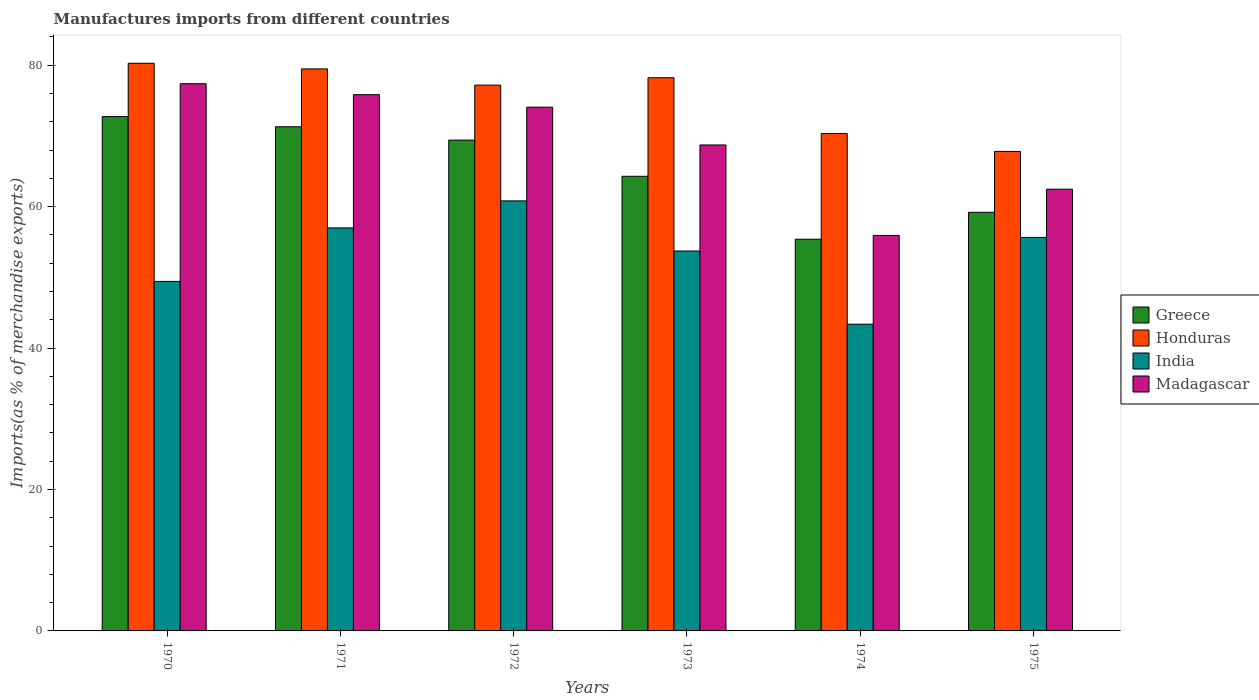Are the number of bars per tick equal to the number of legend labels?
Your answer should be compact. Yes. Are the number of bars on each tick of the X-axis equal?
Your response must be concise. Yes. How many bars are there on the 6th tick from the left?
Your response must be concise. 4. What is the label of the 6th group of bars from the left?
Provide a succinct answer. 1975. In how many cases, is the number of bars for a given year not equal to the number of legend labels?
Provide a short and direct response. 0. What is the percentage of imports to different countries in India in 1971?
Offer a terse response. 56.99. Across all years, what is the maximum percentage of imports to different countries in Greece?
Your response must be concise. 72.73. Across all years, what is the minimum percentage of imports to different countries in Greece?
Keep it short and to the point. 55.39. In which year was the percentage of imports to different countries in India maximum?
Keep it short and to the point. 1972. In which year was the percentage of imports to different countries in India minimum?
Make the answer very short. 1974. What is the total percentage of imports to different countries in India in the graph?
Offer a very short reply. 319.95. What is the difference between the percentage of imports to different countries in Honduras in 1970 and that in 1972?
Your response must be concise. 3.09. What is the difference between the percentage of imports to different countries in Madagascar in 1975 and the percentage of imports to different countries in Greece in 1974?
Keep it short and to the point. 7.08. What is the average percentage of imports to different countries in Madagascar per year?
Offer a very short reply. 69.06. In the year 1972, what is the difference between the percentage of imports to different countries in Honduras and percentage of imports to different countries in Madagascar?
Make the answer very short. 3.11. What is the ratio of the percentage of imports to different countries in Honduras in 1971 to that in 1973?
Offer a terse response. 1.02. Is the difference between the percentage of imports to different countries in Honduras in 1972 and 1974 greater than the difference between the percentage of imports to different countries in Madagascar in 1972 and 1974?
Your answer should be compact. No. What is the difference between the highest and the second highest percentage of imports to different countries in India?
Your answer should be very brief. 3.82. What is the difference between the highest and the lowest percentage of imports to different countries in Greece?
Keep it short and to the point. 17.34. In how many years, is the percentage of imports to different countries in Greece greater than the average percentage of imports to different countries in Greece taken over all years?
Your response must be concise. 3. Is the sum of the percentage of imports to different countries in Greece in 1971 and 1975 greater than the maximum percentage of imports to different countries in Honduras across all years?
Ensure brevity in your answer.  Yes. Is it the case that in every year, the sum of the percentage of imports to different countries in Greece and percentage of imports to different countries in Madagascar is greater than the sum of percentage of imports to different countries in India and percentage of imports to different countries in Honduras?
Ensure brevity in your answer.  No. What does the 1st bar from the left in 1970 represents?
Make the answer very short. Greece. What does the 1st bar from the right in 1972 represents?
Provide a succinct answer. Madagascar. How many bars are there?
Provide a succinct answer. 24. Are all the bars in the graph horizontal?
Offer a terse response. No. How many years are there in the graph?
Offer a terse response. 6. What is the difference between two consecutive major ticks on the Y-axis?
Provide a short and direct response. 20. Are the values on the major ticks of Y-axis written in scientific E-notation?
Offer a terse response. No. Does the graph contain grids?
Ensure brevity in your answer.  No. Where does the legend appear in the graph?
Keep it short and to the point. Center right. How many legend labels are there?
Your answer should be very brief. 4. How are the legend labels stacked?
Your answer should be compact. Vertical. What is the title of the graph?
Keep it short and to the point. Manufactures imports from different countries. What is the label or title of the X-axis?
Provide a short and direct response. Years. What is the label or title of the Y-axis?
Make the answer very short. Imports(as % of merchandise exports). What is the Imports(as % of merchandise exports) in Greece in 1970?
Give a very brief answer. 72.73. What is the Imports(as % of merchandise exports) of Honduras in 1970?
Offer a terse response. 80.27. What is the Imports(as % of merchandise exports) in India in 1970?
Offer a terse response. 49.42. What is the Imports(as % of merchandise exports) in Madagascar in 1970?
Give a very brief answer. 77.37. What is the Imports(as % of merchandise exports) of Greece in 1971?
Offer a terse response. 71.29. What is the Imports(as % of merchandise exports) in Honduras in 1971?
Your answer should be very brief. 79.47. What is the Imports(as % of merchandise exports) of India in 1971?
Offer a very short reply. 56.99. What is the Imports(as % of merchandise exports) of Madagascar in 1971?
Give a very brief answer. 75.83. What is the Imports(as % of merchandise exports) of Greece in 1972?
Ensure brevity in your answer.  69.4. What is the Imports(as % of merchandise exports) in Honduras in 1972?
Your response must be concise. 77.18. What is the Imports(as % of merchandise exports) in India in 1972?
Your answer should be very brief. 60.81. What is the Imports(as % of merchandise exports) in Madagascar in 1972?
Offer a terse response. 74.06. What is the Imports(as % of merchandise exports) of Greece in 1973?
Offer a terse response. 64.29. What is the Imports(as % of merchandise exports) of Honduras in 1973?
Provide a short and direct response. 78.22. What is the Imports(as % of merchandise exports) of India in 1973?
Your response must be concise. 53.72. What is the Imports(as % of merchandise exports) in Madagascar in 1973?
Ensure brevity in your answer.  68.71. What is the Imports(as % of merchandise exports) in Greece in 1974?
Keep it short and to the point. 55.39. What is the Imports(as % of merchandise exports) of Honduras in 1974?
Keep it short and to the point. 70.34. What is the Imports(as % of merchandise exports) in India in 1974?
Your answer should be very brief. 43.37. What is the Imports(as % of merchandise exports) in Madagascar in 1974?
Your answer should be compact. 55.92. What is the Imports(as % of merchandise exports) in Greece in 1975?
Your answer should be very brief. 59.19. What is the Imports(as % of merchandise exports) of Honduras in 1975?
Offer a very short reply. 67.8. What is the Imports(as % of merchandise exports) in India in 1975?
Keep it short and to the point. 55.64. What is the Imports(as % of merchandise exports) of Madagascar in 1975?
Your answer should be very brief. 62.47. Across all years, what is the maximum Imports(as % of merchandise exports) in Greece?
Keep it short and to the point. 72.73. Across all years, what is the maximum Imports(as % of merchandise exports) of Honduras?
Provide a succinct answer. 80.27. Across all years, what is the maximum Imports(as % of merchandise exports) of India?
Your response must be concise. 60.81. Across all years, what is the maximum Imports(as % of merchandise exports) of Madagascar?
Your answer should be compact. 77.37. Across all years, what is the minimum Imports(as % of merchandise exports) in Greece?
Keep it short and to the point. 55.39. Across all years, what is the minimum Imports(as % of merchandise exports) in Honduras?
Keep it short and to the point. 67.8. Across all years, what is the minimum Imports(as % of merchandise exports) in India?
Keep it short and to the point. 43.37. Across all years, what is the minimum Imports(as % of merchandise exports) in Madagascar?
Your response must be concise. 55.92. What is the total Imports(as % of merchandise exports) of Greece in the graph?
Keep it short and to the point. 392.29. What is the total Imports(as % of merchandise exports) of Honduras in the graph?
Keep it short and to the point. 453.28. What is the total Imports(as % of merchandise exports) of India in the graph?
Your answer should be compact. 319.95. What is the total Imports(as % of merchandise exports) of Madagascar in the graph?
Provide a short and direct response. 414.37. What is the difference between the Imports(as % of merchandise exports) in Greece in 1970 and that in 1971?
Your response must be concise. 1.44. What is the difference between the Imports(as % of merchandise exports) in Honduras in 1970 and that in 1971?
Ensure brevity in your answer.  0.8. What is the difference between the Imports(as % of merchandise exports) of India in 1970 and that in 1971?
Provide a short and direct response. -7.56. What is the difference between the Imports(as % of merchandise exports) in Madagascar in 1970 and that in 1971?
Provide a succinct answer. 1.55. What is the difference between the Imports(as % of merchandise exports) in Greece in 1970 and that in 1972?
Offer a terse response. 3.32. What is the difference between the Imports(as % of merchandise exports) in Honduras in 1970 and that in 1972?
Your response must be concise. 3.09. What is the difference between the Imports(as % of merchandise exports) of India in 1970 and that in 1972?
Ensure brevity in your answer.  -11.39. What is the difference between the Imports(as % of merchandise exports) of Madagascar in 1970 and that in 1972?
Make the answer very short. 3.31. What is the difference between the Imports(as % of merchandise exports) of Greece in 1970 and that in 1973?
Make the answer very short. 8.44. What is the difference between the Imports(as % of merchandise exports) of Honduras in 1970 and that in 1973?
Provide a succinct answer. 2.04. What is the difference between the Imports(as % of merchandise exports) in India in 1970 and that in 1973?
Offer a terse response. -4.3. What is the difference between the Imports(as % of merchandise exports) of Madagascar in 1970 and that in 1973?
Make the answer very short. 8.66. What is the difference between the Imports(as % of merchandise exports) of Greece in 1970 and that in 1974?
Ensure brevity in your answer.  17.34. What is the difference between the Imports(as % of merchandise exports) of Honduras in 1970 and that in 1974?
Your answer should be very brief. 9.93. What is the difference between the Imports(as % of merchandise exports) of India in 1970 and that in 1974?
Provide a succinct answer. 6.05. What is the difference between the Imports(as % of merchandise exports) of Madagascar in 1970 and that in 1974?
Keep it short and to the point. 21.45. What is the difference between the Imports(as % of merchandise exports) in Greece in 1970 and that in 1975?
Your response must be concise. 13.53. What is the difference between the Imports(as % of merchandise exports) in Honduras in 1970 and that in 1975?
Offer a very short reply. 12.47. What is the difference between the Imports(as % of merchandise exports) in India in 1970 and that in 1975?
Ensure brevity in your answer.  -6.22. What is the difference between the Imports(as % of merchandise exports) in Madagascar in 1970 and that in 1975?
Your answer should be very brief. 14.91. What is the difference between the Imports(as % of merchandise exports) of Greece in 1971 and that in 1972?
Keep it short and to the point. 1.89. What is the difference between the Imports(as % of merchandise exports) of Honduras in 1971 and that in 1972?
Offer a terse response. 2.29. What is the difference between the Imports(as % of merchandise exports) of India in 1971 and that in 1972?
Your answer should be compact. -3.82. What is the difference between the Imports(as % of merchandise exports) of Madagascar in 1971 and that in 1972?
Provide a short and direct response. 1.77. What is the difference between the Imports(as % of merchandise exports) in Greece in 1971 and that in 1973?
Provide a succinct answer. 7.01. What is the difference between the Imports(as % of merchandise exports) of Honduras in 1971 and that in 1973?
Your answer should be compact. 1.24. What is the difference between the Imports(as % of merchandise exports) in India in 1971 and that in 1973?
Make the answer very short. 3.27. What is the difference between the Imports(as % of merchandise exports) in Madagascar in 1971 and that in 1973?
Your response must be concise. 7.11. What is the difference between the Imports(as % of merchandise exports) of Greece in 1971 and that in 1974?
Offer a very short reply. 15.9. What is the difference between the Imports(as % of merchandise exports) of Honduras in 1971 and that in 1974?
Your answer should be compact. 9.13. What is the difference between the Imports(as % of merchandise exports) of India in 1971 and that in 1974?
Provide a succinct answer. 13.62. What is the difference between the Imports(as % of merchandise exports) in Madagascar in 1971 and that in 1974?
Give a very brief answer. 19.91. What is the difference between the Imports(as % of merchandise exports) of Greece in 1971 and that in 1975?
Offer a very short reply. 12.1. What is the difference between the Imports(as % of merchandise exports) of Honduras in 1971 and that in 1975?
Your answer should be very brief. 11.67. What is the difference between the Imports(as % of merchandise exports) in India in 1971 and that in 1975?
Provide a succinct answer. 1.35. What is the difference between the Imports(as % of merchandise exports) of Madagascar in 1971 and that in 1975?
Give a very brief answer. 13.36. What is the difference between the Imports(as % of merchandise exports) in Greece in 1972 and that in 1973?
Give a very brief answer. 5.12. What is the difference between the Imports(as % of merchandise exports) in Honduras in 1972 and that in 1973?
Provide a short and direct response. -1.05. What is the difference between the Imports(as % of merchandise exports) in India in 1972 and that in 1973?
Ensure brevity in your answer.  7.09. What is the difference between the Imports(as % of merchandise exports) of Madagascar in 1972 and that in 1973?
Your response must be concise. 5.35. What is the difference between the Imports(as % of merchandise exports) in Greece in 1972 and that in 1974?
Provide a succinct answer. 14.01. What is the difference between the Imports(as % of merchandise exports) of Honduras in 1972 and that in 1974?
Give a very brief answer. 6.84. What is the difference between the Imports(as % of merchandise exports) of India in 1972 and that in 1974?
Make the answer very short. 17.44. What is the difference between the Imports(as % of merchandise exports) of Madagascar in 1972 and that in 1974?
Give a very brief answer. 18.14. What is the difference between the Imports(as % of merchandise exports) of Greece in 1972 and that in 1975?
Offer a very short reply. 10.21. What is the difference between the Imports(as % of merchandise exports) in Honduras in 1972 and that in 1975?
Your answer should be compact. 9.37. What is the difference between the Imports(as % of merchandise exports) of India in 1972 and that in 1975?
Provide a short and direct response. 5.17. What is the difference between the Imports(as % of merchandise exports) of Madagascar in 1972 and that in 1975?
Ensure brevity in your answer.  11.6. What is the difference between the Imports(as % of merchandise exports) in Greece in 1973 and that in 1974?
Ensure brevity in your answer.  8.9. What is the difference between the Imports(as % of merchandise exports) of Honduras in 1973 and that in 1974?
Offer a terse response. 7.89. What is the difference between the Imports(as % of merchandise exports) of India in 1973 and that in 1974?
Give a very brief answer. 10.35. What is the difference between the Imports(as % of merchandise exports) of Madagascar in 1973 and that in 1974?
Provide a short and direct response. 12.79. What is the difference between the Imports(as % of merchandise exports) in Greece in 1973 and that in 1975?
Ensure brevity in your answer.  5.09. What is the difference between the Imports(as % of merchandise exports) in Honduras in 1973 and that in 1975?
Give a very brief answer. 10.42. What is the difference between the Imports(as % of merchandise exports) of India in 1973 and that in 1975?
Your answer should be compact. -1.92. What is the difference between the Imports(as % of merchandise exports) of Madagascar in 1973 and that in 1975?
Make the answer very short. 6.25. What is the difference between the Imports(as % of merchandise exports) in Greece in 1974 and that in 1975?
Offer a terse response. -3.81. What is the difference between the Imports(as % of merchandise exports) of Honduras in 1974 and that in 1975?
Provide a short and direct response. 2.54. What is the difference between the Imports(as % of merchandise exports) in India in 1974 and that in 1975?
Your response must be concise. -12.27. What is the difference between the Imports(as % of merchandise exports) of Madagascar in 1974 and that in 1975?
Your response must be concise. -6.54. What is the difference between the Imports(as % of merchandise exports) of Greece in 1970 and the Imports(as % of merchandise exports) of Honduras in 1971?
Your answer should be compact. -6.74. What is the difference between the Imports(as % of merchandise exports) of Greece in 1970 and the Imports(as % of merchandise exports) of India in 1971?
Offer a very short reply. 15.74. What is the difference between the Imports(as % of merchandise exports) of Greece in 1970 and the Imports(as % of merchandise exports) of Madagascar in 1971?
Make the answer very short. -3.1. What is the difference between the Imports(as % of merchandise exports) in Honduras in 1970 and the Imports(as % of merchandise exports) in India in 1971?
Your response must be concise. 23.28. What is the difference between the Imports(as % of merchandise exports) of Honduras in 1970 and the Imports(as % of merchandise exports) of Madagascar in 1971?
Your response must be concise. 4.44. What is the difference between the Imports(as % of merchandise exports) of India in 1970 and the Imports(as % of merchandise exports) of Madagascar in 1971?
Your answer should be very brief. -26.41. What is the difference between the Imports(as % of merchandise exports) in Greece in 1970 and the Imports(as % of merchandise exports) in Honduras in 1972?
Your response must be concise. -4.45. What is the difference between the Imports(as % of merchandise exports) in Greece in 1970 and the Imports(as % of merchandise exports) in India in 1972?
Your response must be concise. 11.92. What is the difference between the Imports(as % of merchandise exports) of Greece in 1970 and the Imports(as % of merchandise exports) of Madagascar in 1972?
Ensure brevity in your answer.  -1.34. What is the difference between the Imports(as % of merchandise exports) of Honduras in 1970 and the Imports(as % of merchandise exports) of India in 1972?
Offer a very short reply. 19.46. What is the difference between the Imports(as % of merchandise exports) of Honduras in 1970 and the Imports(as % of merchandise exports) of Madagascar in 1972?
Provide a succinct answer. 6.21. What is the difference between the Imports(as % of merchandise exports) in India in 1970 and the Imports(as % of merchandise exports) in Madagascar in 1972?
Give a very brief answer. -24.64. What is the difference between the Imports(as % of merchandise exports) in Greece in 1970 and the Imports(as % of merchandise exports) in Honduras in 1973?
Keep it short and to the point. -5.5. What is the difference between the Imports(as % of merchandise exports) of Greece in 1970 and the Imports(as % of merchandise exports) of India in 1973?
Provide a short and direct response. 19.01. What is the difference between the Imports(as % of merchandise exports) in Greece in 1970 and the Imports(as % of merchandise exports) in Madagascar in 1973?
Offer a very short reply. 4.01. What is the difference between the Imports(as % of merchandise exports) of Honduras in 1970 and the Imports(as % of merchandise exports) of India in 1973?
Keep it short and to the point. 26.55. What is the difference between the Imports(as % of merchandise exports) in Honduras in 1970 and the Imports(as % of merchandise exports) in Madagascar in 1973?
Provide a succinct answer. 11.55. What is the difference between the Imports(as % of merchandise exports) in India in 1970 and the Imports(as % of merchandise exports) in Madagascar in 1973?
Ensure brevity in your answer.  -19.29. What is the difference between the Imports(as % of merchandise exports) of Greece in 1970 and the Imports(as % of merchandise exports) of Honduras in 1974?
Keep it short and to the point. 2.39. What is the difference between the Imports(as % of merchandise exports) in Greece in 1970 and the Imports(as % of merchandise exports) in India in 1974?
Ensure brevity in your answer.  29.35. What is the difference between the Imports(as % of merchandise exports) in Greece in 1970 and the Imports(as % of merchandise exports) in Madagascar in 1974?
Give a very brief answer. 16.8. What is the difference between the Imports(as % of merchandise exports) of Honduras in 1970 and the Imports(as % of merchandise exports) of India in 1974?
Your response must be concise. 36.9. What is the difference between the Imports(as % of merchandise exports) of Honduras in 1970 and the Imports(as % of merchandise exports) of Madagascar in 1974?
Your response must be concise. 24.35. What is the difference between the Imports(as % of merchandise exports) of India in 1970 and the Imports(as % of merchandise exports) of Madagascar in 1974?
Your response must be concise. -6.5. What is the difference between the Imports(as % of merchandise exports) in Greece in 1970 and the Imports(as % of merchandise exports) in Honduras in 1975?
Offer a very short reply. 4.92. What is the difference between the Imports(as % of merchandise exports) of Greece in 1970 and the Imports(as % of merchandise exports) of India in 1975?
Provide a succinct answer. 17.09. What is the difference between the Imports(as % of merchandise exports) in Greece in 1970 and the Imports(as % of merchandise exports) in Madagascar in 1975?
Give a very brief answer. 10.26. What is the difference between the Imports(as % of merchandise exports) in Honduras in 1970 and the Imports(as % of merchandise exports) in India in 1975?
Provide a succinct answer. 24.63. What is the difference between the Imports(as % of merchandise exports) of Honduras in 1970 and the Imports(as % of merchandise exports) of Madagascar in 1975?
Give a very brief answer. 17.8. What is the difference between the Imports(as % of merchandise exports) in India in 1970 and the Imports(as % of merchandise exports) in Madagascar in 1975?
Give a very brief answer. -13.04. What is the difference between the Imports(as % of merchandise exports) in Greece in 1971 and the Imports(as % of merchandise exports) in Honduras in 1972?
Keep it short and to the point. -5.88. What is the difference between the Imports(as % of merchandise exports) in Greece in 1971 and the Imports(as % of merchandise exports) in India in 1972?
Ensure brevity in your answer.  10.48. What is the difference between the Imports(as % of merchandise exports) of Greece in 1971 and the Imports(as % of merchandise exports) of Madagascar in 1972?
Make the answer very short. -2.77. What is the difference between the Imports(as % of merchandise exports) in Honduras in 1971 and the Imports(as % of merchandise exports) in India in 1972?
Ensure brevity in your answer.  18.66. What is the difference between the Imports(as % of merchandise exports) of Honduras in 1971 and the Imports(as % of merchandise exports) of Madagascar in 1972?
Offer a terse response. 5.41. What is the difference between the Imports(as % of merchandise exports) in India in 1971 and the Imports(as % of merchandise exports) in Madagascar in 1972?
Your answer should be compact. -17.08. What is the difference between the Imports(as % of merchandise exports) in Greece in 1971 and the Imports(as % of merchandise exports) in Honduras in 1973?
Keep it short and to the point. -6.93. What is the difference between the Imports(as % of merchandise exports) of Greece in 1971 and the Imports(as % of merchandise exports) of India in 1973?
Give a very brief answer. 17.57. What is the difference between the Imports(as % of merchandise exports) in Greece in 1971 and the Imports(as % of merchandise exports) in Madagascar in 1973?
Provide a succinct answer. 2.58. What is the difference between the Imports(as % of merchandise exports) in Honduras in 1971 and the Imports(as % of merchandise exports) in India in 1973?
Provide a short and direct response. 25.75. What is the difference between the Imports(as % of merchandise exports) in Honduras in 1971 and the Imports(as % of merchandise exports) in Madagascar in 1973?
Your response must be concise. 10.75. What is the difference between the Imports(as % of merchandise exports) of India in 1971 and the Imports(as % of merchandise exports) of Madagascar in 1973?
Make the answer very short. -11.73. What is the difference between the Imports(as % of merchandise exports) in Greece in 1971 and the Imports(as % of merchandise exports) in Honduras in 1974?
Offer a very short reply. 0.95. What is the difference between the Imports(as % of merchandise exports) in Greece in 1971 and the Imports(as % of merchandise exports) in India in 1974?
Provide a succinct answer. 27.92. What is the difference between the Imports(as % of merchandise exports) of Greece in 1971 and the Imports(as % of merchandise exports) of Madagascar in 1974?
Offer a terse response. 15.37. What is the difference between the Imports(as % of merchandise exports) of Honduras in 1971 and the Imports(as % of merchandise exports) of India in 1974?
Ensure brevity in your answer.  36.1. What is the difference between the Imports(as % of merchandise exports) in Honduras in 1971 and the Imports(as % of merchandise exports) in Madagascar in 1974?
Ensure brevity in your answer.  23.55. What is the difference between the Imports(as % of merchandise exports) of India in 1971 and the Imports(as % of merchandise exports) of Madagascar in 1974?
Your answer should be very brief. 1.06. What is the difference between the Imports(as % of merchandise exports) of Greece in 1971 and the Imports(as % of merchandise exports) of Honduras in 1975?
Provide a short and direct response. 3.49. What is the difference between the Imports(as % of merchandise exports) of Greece in 1971 and the Imports(as % of merchandise exports) of India in 1975?
Your answer should be compact. 15.65. What is the difference between the Imports(as % of merchandise exports) of Greece in 1971 and the Imports(as % of merchandise exports) of Madagascar in 1975?
Your answer should be very brief. 8.83. What is the difference between the Imports(as % of merchandise exports) of Honduras in 1971 and the Imports(as % of merchandise exports) of India in 1975?
Offer a very short reply. 23.83. What is the difference between the Imports(as % of merchandise exports) in Honduras in 1971 and the Imports(as % of merchandise exports) in Madagascar in 1975?
Make the answer very short. 17. What is the difference between the Imports(as % of merchandise exports) of India in 1971 and the Imports(as % of merchandise exports) of Madagascar in 1975?
Your response must be concise. -5.48. What is the difference between the Imports(as % of merchandise exports) of Greece in 1972 and the Imports(as % of merchandise exports) of Honduras in 1973?
Your response must be concise. -8.82. What is the difference between the Imports(as % of merchandise exports) of Greece in 1972 and the Imports(as % of merchandise exports) of India in 1973?
Provide a succinct answer. 15.68. What is the difference between the Imports(as % of merchandise exports) of Greece in 1972 and the Imports(as % of merchandise exports) of Madagascar in 1973?
Your answer should be compact. 0.69. What is the difference between the Imports(as % of merchandise exports) of Honduras in 1972 and the Imports(as % of merchandise exports) of India in 1973?
Your answer should be compact. 23.45. What is the difference between the Imports(as % of merchandise exports) in Honduras in 1972 and the Imports(as % of merchandise exports) in Madagascar in 1973?
Offer a very short reply. 8.46. What is the difference between the Imports(as % of merchandise exports) in India in 1972 and the Imports(as % of merchandise exports) in Madagascar in 1973?
Offer a terse response. -7.91. What is the difference between the Imports(as % of merchandise exports) in Greece in 1972 and the Imports(as % of merchandise exports) in Honduras in 1974?
Offer a terse response. -0.94. What is the difference between the Imports(as % of merchandise exports) of Greece in 1972 and the Imports(as % of merchandise exports) of India in 1974?
Provide a short and direct response. 26.03. What is the difference between the Imports(as % of merchandise exports) of Greece in 1972 and the Imports(as % of merchandise exports) of Madagascar in 1974?
Your answer should be very brief. 13.48. What is the difference between the Imports(as % of merchandise exports) in Honduras in 1972 and the Imports(as % of merchandise exports) in India in 1974?
Offer a very short reply. 33.8. What is the difference between the Imports(as % of merchandise exports) of Honduras in 1972 and the Imports(as % of merchandise exports) of Madagascar in 1974?
Keep it short and to the point. 21.25. What is the difference between the Imports(as % of merchandise exports) in India in 1972 and the Imports(as % of merchandise exports) in Madagascar in 1974?
Offer a terse response. 4.89. What is the difference between the Imports(as % of merchandise exports) in Greece in 1972 and the Imports(as % of merchandise exports) in Honduras in 1975?
Provide a succinct answer. 1.6. What is the difference between the Imports(as % of merchandise exports) in Greece in 1972 and the Imports(as % of merchandise exports) in India in 1975?
Offer a terse response. 13.76. What is the difference between the Imports(as % of merchandise exports) of Greece in 1972 and the Imports(as % of merchandise exports) of Madagascar in 1975?
Your answer should be very brief. 6.94. What is the difference between the Imports(as % of merchandise exports) of Honduras in 1972 and the Imports(as % of merchandise exports) of India in 1975?
Your answer should be very brief. 21.53. What is the difference between the Imports(as % of merchandise exports) in Honduras in 1972 and the Imports(as % of merchandise exports) in Madagascar in 1975?
Make the answer very short. 14.71. What is the difference between the Imports(as % of merchandise exports) of India in 1972 and the Imports(as % of merchandise exports) of Madagascar in 1975?
Provide a succinct answer. -1.66. What is the difference between the Imports(as % of merchandise exports) in Greece in 1973 and the Imports(as % of merchandise exports) in Honduras in 1974?
Keep it short and to the point. -6.05. What is the difference between the Imports(as % of merchandise exports) in Greece in 1973 and the Imports(as % of merchandise exports) in India in 1974?
Ensure brevity in your answer.  20.91. What is the difference between the Imports(as % of merchandise exports) in Greece in 1973 and the Imports(as % of merchandise exports) in Madagascar in 1974?
Offer a terse response. 8.36. What is the difference between the Imports(as % of merchandise exports) in Honduras in 1973 and the Imports(as % of merchandise exports) in India in 1974?
Make the answer very short. 34.85. What is the difference between the Imports(as % of merchandise exports) of Honduras in 1973 and the Imports(as % of merchandise exports) of Madagascar in 1974?
Keep it short and to the point. 22.3. What is the difference between the Imports(as % of merchandise exports) in India in 1973 and the Imports(as % of merchandise exports) in Madagascar in 1974?
Keep it short and to the point. -2.2. What is the difference between the Imports(as % of merchandise exports) in Greece in 1973 and the Imports(as % of merchandise exports) in Honduras in 1975?
Your response must be concise. -3.52. What is the difference between the Imports(as % of merchandise exports) of Greece in 1973 and the Imports(as % of merchandise exports) of India in 1975?
Offer a very short reply. 8.64. What is the difference between the Imports(as % of merchandise exports) of Greece in 1973 and the Imports(as % of merchandise exports) of Madagascar in 1975?
Offer a very short reply. 1.82. What is the difference between the Imports(as % of merchandise exports) of Honduras in 1973 and the Imports(as % of merchandise exports) of India in 1975?
Make the answer very short. 22.58. What is the difference between the Imports(as % of merchandise exports) in Honduras in 1973 and the Imports(as % of merchandise exports) in Madagascar in 1975?
Ensure brevity in your answer.  15.76. What is the difference between the Imports(as % of merchandise exports) of India in 1973 and the Imports(as % of merchandise exports) of Madagascar in 1975?
Offer a very short reply. -8.74. What is the difference between the Imports(as % of merchandise exports) in Greece in 1974 and the Imports(as % of merchandise exports) in Honduras in 1975?
Ensure brevity in your answer.  -12.41. What is the difference between the Imports(as % of merchandise exports) in Greece in 1974 and the Imports(as % of merchandise exports) in India in 1975?
Make the answer very short. -0.25. What is the difference between the Imports(as % of merchandise exports) of Greece in 1974 and the Imports(as % of merchandise exports) of Madagascar in 1975?
Provide a short and direct response. -7.08. What is the difference between the Imports(as % of merchandise exports) of Honduras in 1974 and the Imports(as % of merchandise exports) of India in 1975?
Offer a terse response. 14.7. What is the difference between the Imports(as % of merchandise exports) of Honduras in 1974 and the Imports(as % of merchandise exports) of Madagascar in 1975?
Offer a terse response. 7.87. What is the difference between the Imports(as % of merchandise exports) in India in 1974 and the Imports(as % of merchandise exports) in Madagascar in 1975?
Your answer should be very brief. -19.09. What is the average Imports(as % of merchandise exports) in Greece per year?
Keep it short and to the point. 65.38. What is the average Imports(as % of merchandise exports) of Honduras per year?
Offer a terse response. 75.55. What is the average Imports(as % of merchandise exports) of India per year?
Ensure brevity in your answer.  53.33. What is the average Imports(as % of merchandise exports) of Madagascar per year?
Your response must be concise. 69.06. In the year 1970, what is the difference between the Imports(as % of merchandise exports) in Greece and Imports(as % of merchandise exports) in Honduras?
Offer a very short reply. -7.54. In the year 1970, what is the difference between the Imports(as % of merchandise exports) of Greece and Imports(as % of merchandise exports) of India?
Make the answer very short. 23.3. In the year 1970, what is the difference between the Imports(as % of merchandise exports) in Greece and Imports(as % of merchandise exports) in Madagascar?
Your answer should be compact. -4.65. In the year 1970, what is the difference between the Imports(as % of merchandise exports) of Honduras and Imports(as % of merchandise exports) of India?
Keep it short and to the point. 30.85. In the year 1970, what is the difference between the Imports(as % of merchandise exports) in Honduras and Imports(as % of merchandise exports) in Madagascar?
Make the answer very short. 2.9. In the year 1970, what is the difference between the Imports(as % of merchandise exports) of India and Imports(as % of merchandise exports) of Madagascar?
Provide a succinct answer. -27.95. In the year 1971, what is the difference between the Imports(as % of merchandise exports) in Greece and Imports(as % of merchandise exports) in Honduras?
Provide a succinct answer. -8.18. In the year 1971, what is the difference between the Imports(as % of merchandise exports) in Greece and Imports(as % of merchandise exports) in India?
Ensure brevity in your answer.  14.3. In the year 1971, what is the difference between the Imports(as % of merchandise exports) in Greece and Imports(as % of merchandise exports) in Madagascar?
Your answer should be very brief. -4.54. In the year 1971, what is the difference between the Imports(as % of merchandise exports) of Honduras and Imports(as % of merchandise exports) of India?
Your response must be concise. 22.48. In the year 1971, what is the difference between the Imports(as % of merchandise exports) in Honduras and Imports(as % of merchandise exports) in Madagascar?
Offer a terse response. 3.64. In the year 1971, what is the difference between the Imports(as % of merchandise exports) of India and Imports(as % of merchandise exports) of Madagascar?
Your answer should be compact. -18.84. In the year 1972, what is the difference between the Imports(as % of merchandise exports) of Greece and Imports(as % of merchandise exports) of Honduras?
Your answer should be compact. -7.77. In the year 1972, what is the difference between the Imports(as % of merchandise exports) of Greece and Imports(as % of merchandise exports) of India?
Provide a succinct answer. 8.59. In the year 1972, what is the difference between the Imports(as % of merchandise exports) of Greece and Imports(as % of merchandise exports) of Madagascar?
Your answer should be very brief. -4.66. In the year 1972, what is the difference between the Imports(as % of merchandise exports) of Honduras and Imports(as % of merchandise exports) of India?
Make the answer very short. 16.37. In the year 1972, what is the difference between the Imports(as % of merchandise exports) in Honduras and Imports(as % of merchandise exports) in Madagascar?
Give a very brief answer. 3.11. In the year 1972, what is the difference between the Imports(as % of merchandise exports) of India and Imports(as % of merchandise exports) of Madagascar?
Make the answer very short. -13.25. In the year 1973, what is the difference between the Imports(as % of merchandise exports) of Greece and Imports(as % of merchandise exports) of Honduras?
Your response must be concise. -13.94. In the year 1973, what is the difference between the Imports(as % of merchandise exports) of Greece and Imports(as % of merchandise exports) of India?
Your response must be concise. 10.56. In the year 1973, what is the difference between the Imports(as % of merchandise exports) of Greece and Imports(as % of merchandise exports) of Madagascar?
Your answer should be compact. -4.43. In the year 1973, what is the difference between the Imports(as % of merchandise exports) in Honduras and Imports(as % of merchandise exports) in India?
Your response must be concise. 24.5. In the year 1973, what is the difference between the Imports(as % of merchandise exports) of Honduras and Imports(as % of merchandise exports) of Madagascar?
Offer a terse response. 9.51. In the year 1973, what is the difference between the Imports(as % of merchandise exports) in India and Imports(as % of merchandise exports) in Madagascar?
Your response must be concise. -14.99. In the year 1974, what is the difference between the Imports(as % of merchandise exports) of Greece and Imports(as % of merchandise exports) of Honduras?
Provide a short and direct response. -14.95. In the year 1974, what is the difference between the Imports(as % of merchandise exports) in Greece and Imports(as % of merchandise exports) in India?
Your answer should be very brief. 12.02. In the year 1974, what is the difference between the Imports(as % of merchandise exports) of Greece and Imports(as % of merchandise exports) of Madagascar?
Provide a succinct answer. -0.54. In the year 1974, what is the difference between the Imports(as % of merchandise exports) in Honduras and Imports(as % of merchandise exports) in India?
Ensure brevity in your answer.  26.97. In the year 1974, what is the difference between the Imports(as % of merchandise exports) in Honduras and Imports(as % of merchandise exports) in Madagascar?
Your answer should be compact. 14.41. In the year 1974, what is the difference between the Imports(as % of merchandise exports) in India and Imports(as % of merchandise exports) in Madagascar?
Provide a short and direct response. -12.55. In the year 1975, what is the difference between the Imports(as % of merchandise exports) of Greece and Imports(as % of merchandise exports) of Honduras?
Offer a very short reply. -8.61. In the year 1975, what is the difference between the Imports(as % of merchandise exports) in Greece and Imports(as % of merchandise exports) in India?
Your response must be concise. 3.55. In the year 1975, what is the difference between the Imports(as % of merchandise exports) of Greece and Imports(as % of merchandise exports) of Madagascar?
Your answer should be compact. -3.27. In the year 1975, what is the difference between the Imports(as % of merchandise exports) of Honduras and Imports(as % of merchandise exports) of India?
Ensure brevity in your answer.  12.16. In the year 1975, what is the difference between the Imports(as % of merchandise exports) in Honduras and Imports(as % of merchandise exports) in Madagascar?
Provide a short and direct response. 5.34. In the year 1975, what is the difference between the Imports(as % of merchandise exports) in India and Imports(as % of merchandise exports) in Madagascar?
Your answer should be very brief. -6.82. What is the ratio of the Imports(as % of merchandise exports) of Greece in 1970 to that in 1971?
Offer a terse response. 1.02. What is the ratio of the Imports(as % of merchandise exports) in Honduras in 1970 to that in 1971?
Ensure brevity in your answer.  1.01. What is the ratio of the Imports(as % of merchandise exports) in India in 1970 to that in 1971?
Your answer should be very brief. 0.87. What is the ratio of the Imports(as % of merchandise exports) of Madagascar in 1970 to that in 1971?
Keep it short and to the point. 1.02. What is the ratio of the Imports(as % of merchandise exports) in Greece in 1970 to that in 1972?
Ensure brevity in your answer.  1.05. What is the ratio of the Imports(as % of merchandise exports) of Honduras in 1970 to that in 1972?
Your answer should be compact. 1.04. What is the ratio of the Imports(as % of merchandise exports) of India in 1970 to that in 1972?
Offer a terse response. 0.81. What is the ratio of the Imports(as % of merchandise exports) of Madagascar in 1970 to that in 1972?
Offer a terse response. 1.04. What is the ratio of the Imports(as % of merchandise exports) of Greece in 1970 to that in 1973?
Offer a terse response. 1.13. What is the ratio of the Imports(as % of merchandise exports) in Honduras in 1970 to that in 1973?
Your answer should be compact. 1.03. What is the ratio of the Imports(as % of merchandise exports) in Madagascar in 1970 to that in 1973?
Your answer should be compact. 1.13. What is the ratio of the Imports(as % of merchandise exports) in Greece in 1970 to that in 1974?
Ensure brevity in your answer.  1.31. What is the ratio of the Imports(as % of merchandise exports) of Honduras in 1970 to that in 1974?
Your answer should be compact. 1.14. What is the ratio of the Imports(as % of merchandise exports) in India in 1970 to that in 1974?
Ensure brevity in your answer.  1.14. What is the ratio of the Imports(as % of merchandise exports) in Madagascar in 1970 to that in 1974?
Provide a short and direct response. 1.38. What is the ratio of the Imports(as % of merchandise exports) of Greece in 1970 to that in 1975?
Provide a short and direct response. 1.23. What is the ratio of the Imports(as % of merchandise exports) of Honduras in 1970 to that in 1975?
Offer a very short reply. 1.18. What is the ratio of the Imports(as % of merchandise exports) of India in 1970 to that in 1975?
Ensure brevity in your answer.  0.89. What is the ratio of the Imports(as % of merchandise exports) in Madagascar in 1970 to that in 1975?
Keep it short and to the point. 1.24. What is the ratio of the Imports(as % of merchandise exports) in Greece in 1971 to that in 1972?
Offer a terse response. 1.03. What is the ratio of the Imports(as % of merchandise exports) in Honduras in 1971 to that in 1972?
Give a very brief answer. 1.03. What is the ratio of the Imports(as % of merchandise exports) in India in 1971 to that in 1972?
Your answer should be very brief. 0.94. What is the ratio of the Imports(as % of merchandise exports) in Madagascar in 1971 to that in 1972?
Offer a very short reply. 1.02. What is the ratio of the Imports(as % of merchandise exports) of Greece in 1971 to that in 1973?
Make the answer very short. 1.11. What is the ratio of the Imports(as % of merchandise exports) in Honduras in 1971 to that in 1973?
Ensure brevity in your answer.  1.02. What is the ratio of the Imports(as % of merchandise exports) of India in 1971 to that in 1973?
Your answer should be compact. 1.06. What is the ratio of the Imports(as % of merchandise exports) in Madagascar in 1971 to that in 1973?
Provide a short and direct response. 1.1. What is the ratio of the Imports(as % of merchandise exports) in Greece in 1971 to that in 1974?
Your answer should be compact. 1.29. What is the ratio of the Imports(as % of merchandise exports) in Honduras in 1971 to that in 1974?
Ensure brevity in your answer.  1.13. What is the ratio of the Imports(as % of merchandise exports) of India in 1971 to that in 1974?
Make the answer very short. 1.31. What is the ratio of the Imports(as % of merchandise exports) in Madagascar in 1971 to that in 1974?
Your response must be concise. 1.36. What is the ratio of the Imports(as % of merchandise exports) of Greece in 1971 to that in 1975?
Make the answer very short. 1.2. What is the ratio of the Imports(as % of merchandise exports) in Honduras in 1971 to that in 1975?
Your answer should be very brief. 1.17. What is the ratio of the Imports(as % of merchandise exports) of India in 1971 to that in 1975?
Offer a terse response. 1.02. What is the ratio of the Imports(as % of merchandise exports) in Madagascar in 1971 to that in 1975?
Your answer should be compact. 1.21. What is the ratio of the Imports(as % of merchandise exports) in Greece in 1972 to that in 1973?
Your answer should be very brief. 1.08. What is the ratio of the Imports(as % of merchandise exports) of Honduras in 1972 to that in 1973?
Your response must be concise. 0.99. What is the ratio of the Imports(as % of merchandise exports) in India in 1972 to that in 1973?
Your answer should be compact. 1.13. What is the ratio of the Imports(as % of merchandise exports) in Madagascar in 1972 to that in 1973?
Provide a succinct answer. 1.08. What is the ratio of the Imports(as % of merchandise exports) in Greece in 1972 to that in 1974?
Offer a very short reply. 1.25. What is the ratio of the Imports(as % of merchandise exports) of Honduras in 1972 to that in 1974?
Make the answer very short. 1.1. What is the ratio of the Imports(as % of merchandise exports) in India in 1972 to that in 1974?
Offer a terse response. 1.4. What is the ratio of the Imports(as % of merchandise exports) of Madagascar in 1972 to that in 1974?
Your response must be concise. 1.32. What is the ratio of the Imports(as % of merchandise exports) of Greece in 1972 to that in 1975?
Provide a short and direct response. 1.17. What is the ratio of the Imports(as % of merchandise exports) of Honduras in 1972 to that in 1975?
Ensure brevity in your answer.  1.14. What is the ratio of the Imports(as % of merchandise exports) in India in 1972 to that in 1975?
Make the answer very short. 1.09. What is the ratio of the Imports(as % of merchandise exports) in Madagascar in 1972 to that in 1975?
Your answer should be very brief. 1.19. What is the ratio of the Imports(as % of merchandise exports) in Greece in 1973 to that in 1974?
Your answer should be very brief. 1.16. What is the ratio of the Imports(as % of merchandise exports) in Honduras in 1973 to that in 1974?
Provide a succinct answer. 1.11. What is the ratio of the Imports(as % of merchandise exports) of India in 1973 to that in 1974?
Make the answer very short. 1.24. What is the ratio of the Imports(as % of merchandise exports) in Madagascar in 1973 to that in 1974?
Ensure brevity in your answer.  1.23. What is the ratio of the Imports(as % of merchandise exports) in Greece in 1973 to that in 1975?
Make the answer very short. 1.09. What is the ratio of the Imports(as % of merchandise exports) in Honduras in 1973 to that in 1975?
Your answer should be compact. 1.15. What is the ratio of the Imports(as % of merchandise exports) of India in 1973 to that in 1975?
Give a very brief answer. 0.97. What is the ratio of the Imports(as % of merchandise exports) of Madagascar in 1973 to that in 1975?
Your answer should be compact. 1.1. What is the ratio of the Imports(as % of merchandise exports) of Greece in 1974 to that in 1975?
Your response must be concise. 0.94. What is the ratio of the Imports(as % of merchandise exports) of Honduras in 1974 to that in 1975?
Your response must be concise. 1.04. What is the ratio of the Imports(as % of merchandise exports) of India in 1974 to that in 1975?
Your response must be concise. 0.78. What is the ratio of the Imports(as % of merchandise exports) of Madagascar in 1974 to that in 1975?
Keep it short and to the point. 0.9. What is the difference between the highest and the second highest Imports(as % of merchandise exports) in Greece?
Offer a terse response. 1.44. What is the difference between the highest and the second highest Imports(as % of merchandise exports) in Honduras?
Give a very brief answer. 0.8. What is the difference between the highest and the second highest Imports(as % of merchandise exports) in India?
Ensure brevity in your answer.  3.82. What is the difference between the highest and the second highest Imports(as % of merchandise exports) of Madagascar?
Your response must be concise. 1.55. What is the difference between the highest and the lowest Imports(as % of merchandise exports) of Greece?
Make the answer very short. 17.34. What is the difference between the highest and the lowest Imports(as % of merchandise exports) in Honduras?
Make the answer very short. 12.47. What is the difference between the highest and the lowest Imports(as % of merchandise exports) of India?
Give a very brief answer. 17.44. What is the difference between the highest and the lowest Imports(as % of merchandise exports) in Madagascar?
Keep it short and to the point. 21.45. 